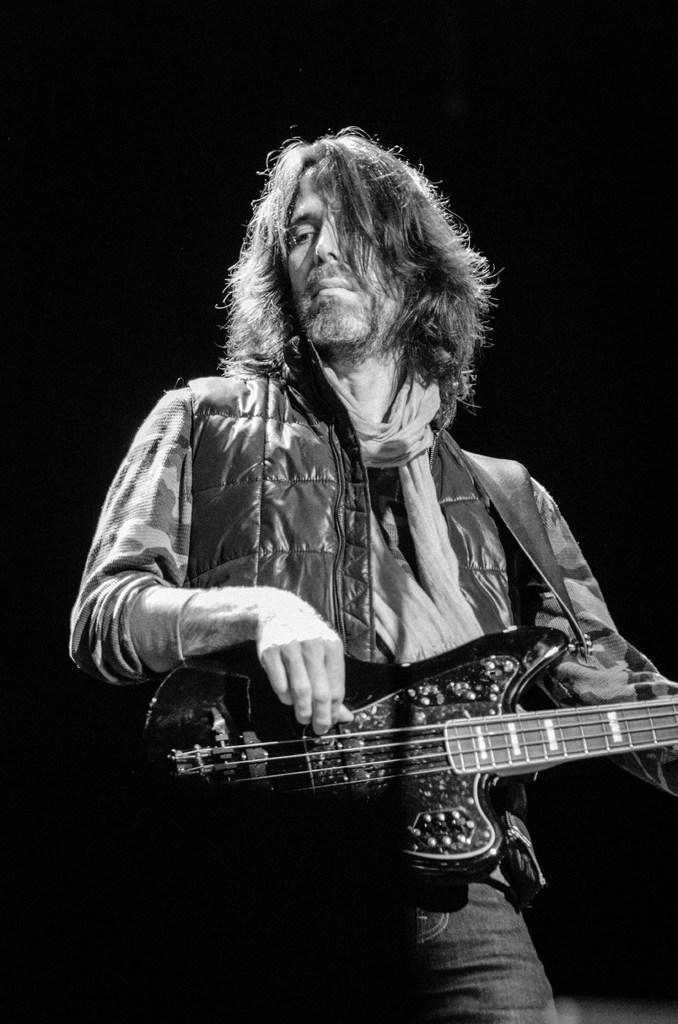How would you summarize this image in a sentence or two? This is a black and white picture, in this picture the man holding the guitar and the background of this man is in black color. 